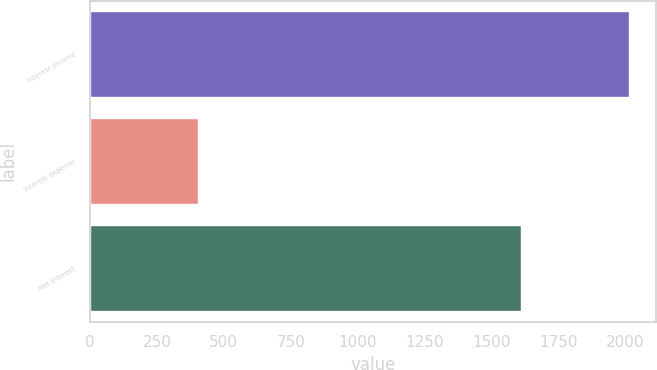<chart> <loc_0><loc_0><loc_500><loc_500><bar_chart><fcel>Interest income<fcel>Interest expense<fcel>Net interest<nl><fcel>2015<fcel>403<fcel>1612<nl></chart> 